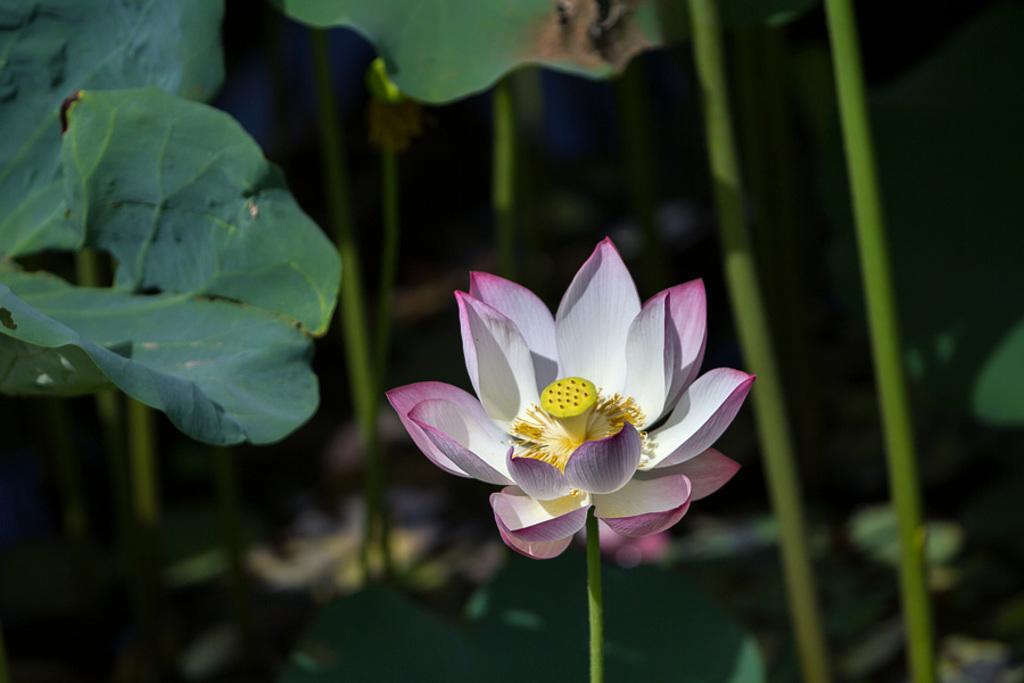In one or two sentences, can you explain what this image depicts? In the middle we can see a flower. In the background there are plants. 